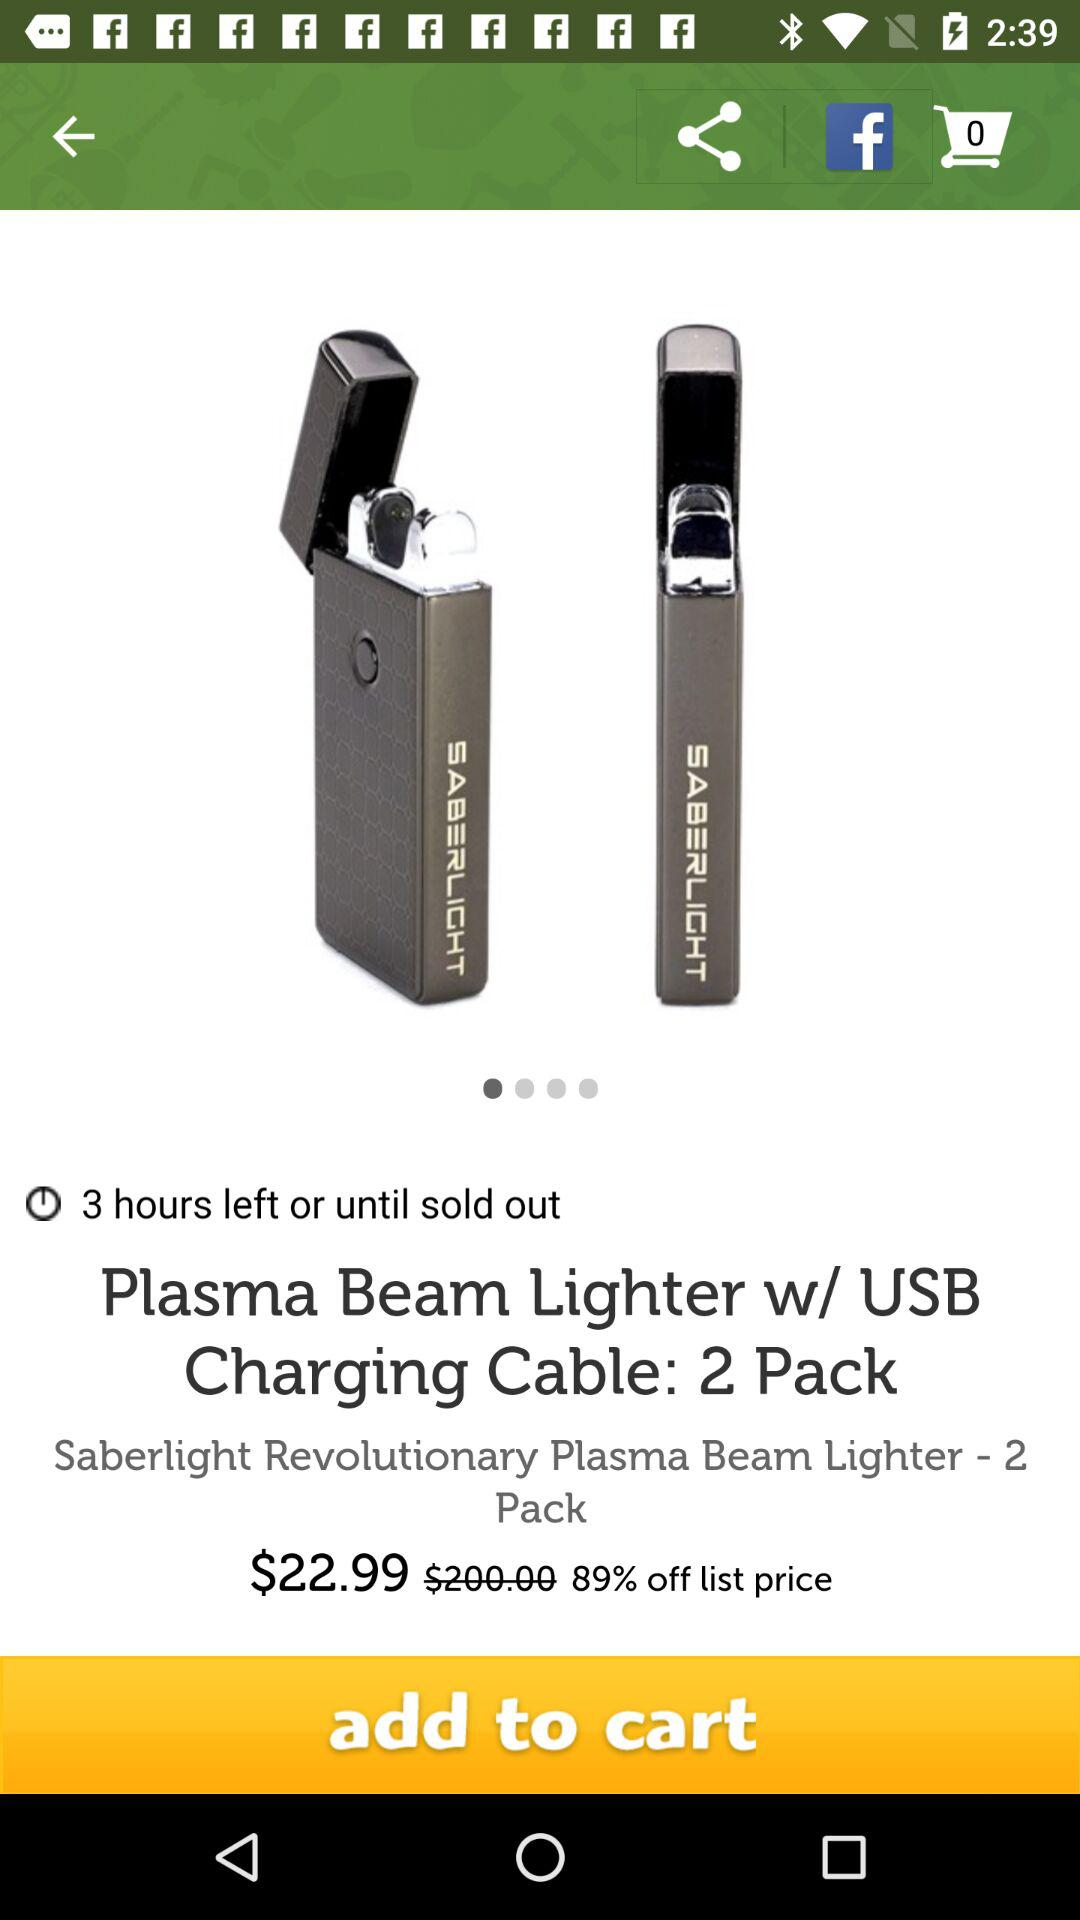How many items are in the cart? There are 0 items in the cart. 